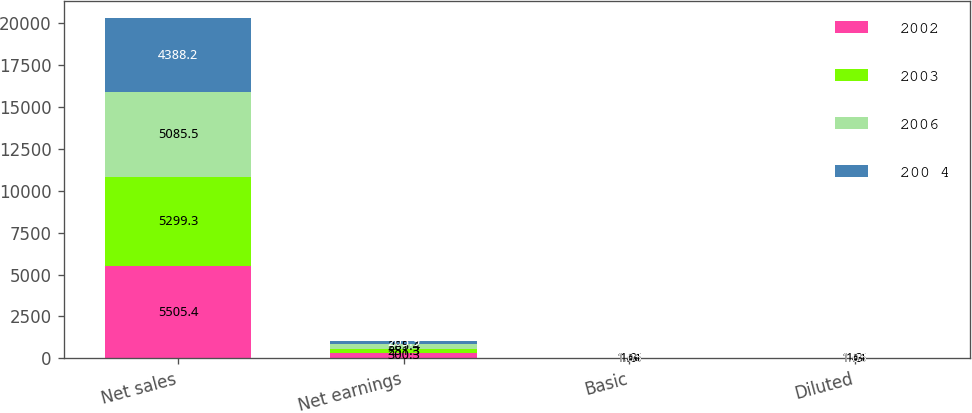<chart> <loc_0><loc_0><loc_500><loc_500><stacked_bar_chart><ecel><fcel>Net sales<fcel>Net earnings<fcel>Basic<fcel>Diluted<nl><fcel>2002<fcel>5505.4<fcel>300.3<fcel>1.61<fcel>1.61<nl><fcel>2003<fcel>5299.3<fcel>251.3<fcel>1.3<fcel>1.3<nl><fcel>2006<fcel>5085.5<fcel>285.4<fcel>1.46<fcel>1.45<nl><fcel>200 4<fcel>4388.2<fcel>205.9<fcel>1.05<fcel>1.05<nl></chart> 